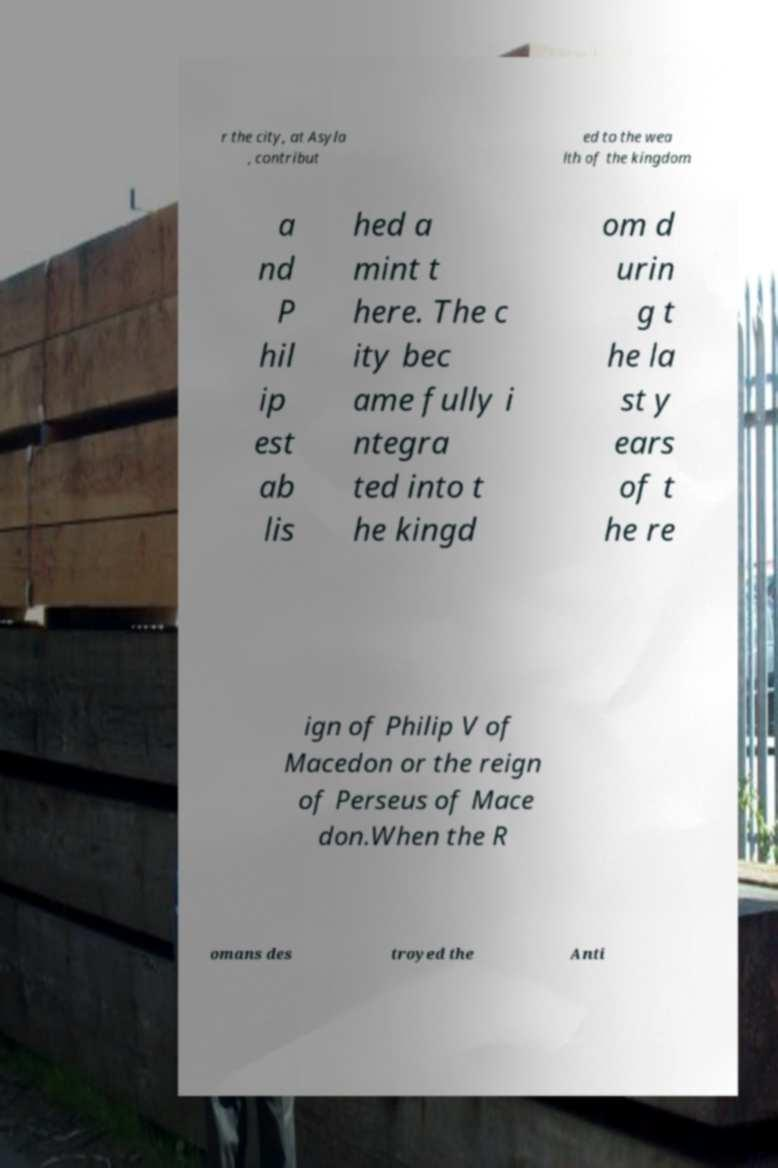Please read and relay the text visible in this image. What does it say? r the city, at Asyla , contribut ed to the wea lth of the kingdom a nd P hil ip est ab lis hed a mint t here. The c ity bec ame fully i ntegra ted into t he kingd om d urin g t he la st y ears of t he re ign of Philip V of Macedon or the reign of Perseus of Mace don.When the R omans des troyed the Anti 